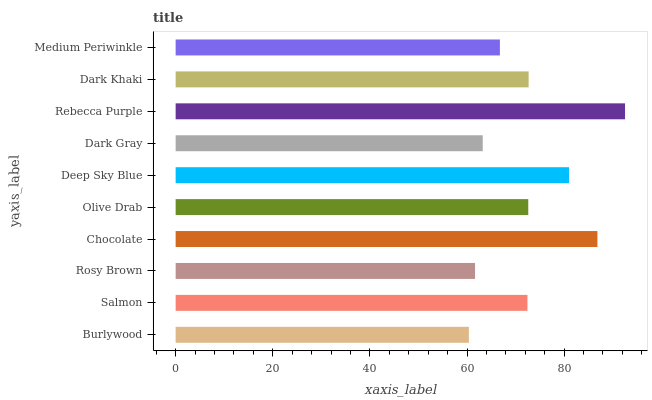Is Burlywood the minimum?
Answer yes or no. Yes. Is Rebecca Purple the maximum?
Answer yes or no. Yes. Is Salmon the minimum?
Answer yes or no. No. Is Salmon the maximum?
Answer yes or no. No. Is Salmon greater than Burlywood?
Answer yes or no. Yes. Is Burlywood less than Salmon?
Answer yes or no. Yes. Is Burlywood greater than Salmon?
Answer yes or no. No. Is Salmon less than Burlywood?
Answer yes or no. No. Is Olive Drab the high median?
Answer yes or no. Yes. Is Salmon the low median?
Answer yes or no. Yes. Is Dark Khaki the high median?
Answer yes or no. No. Is Olive Drab the low median?
Answer yes or no. No. 